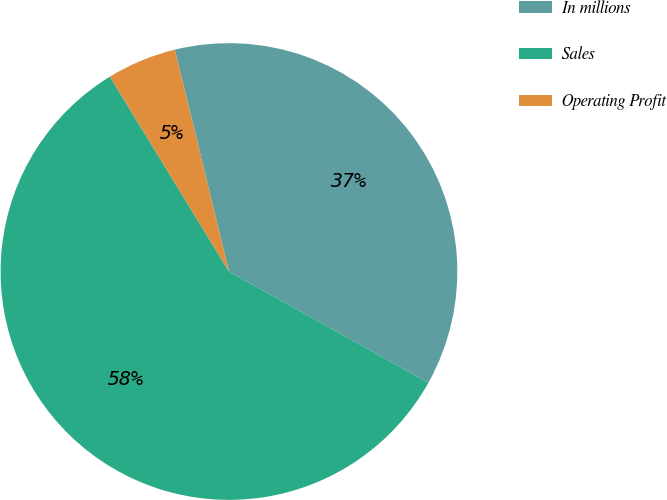<chart> <loc_0><loc_0><loc_500><loc_500><pie_chart><fcel>In millions<fcel>Sales<fcel>Operating Profit<nl><fcel>36.92%<fcel>58.17%<fcel>4.92%<nl></chart> 